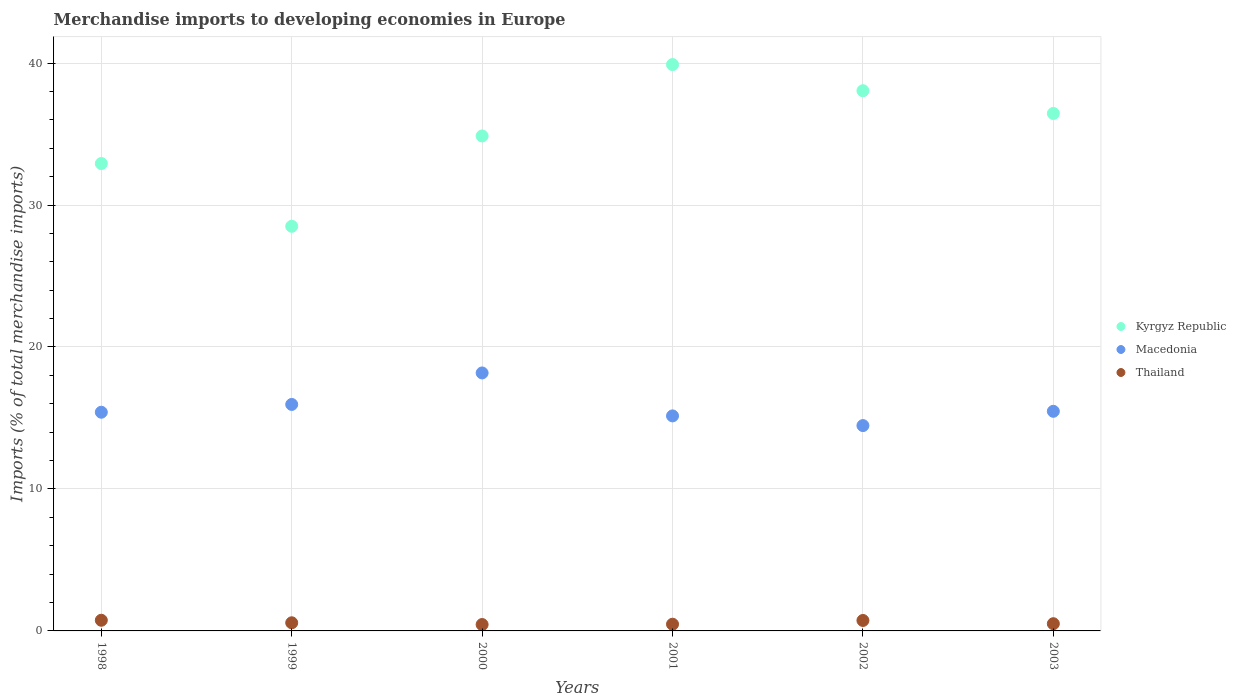How many different coloured dotlines are there?
Your answer should be compact. 3. What is the percentage total merchandise imports in Thailand in 2000?
Offer a very short reply. 0.45. Across all years, what is the maximum percentage total merchandise imports in Macedonia?
Offer a terse response. 18.17. Across all years, what is the minimum percentage total merchandise imports in Kyrgyz Republic?
Offer a very short reply. 28.5. In which year was the percentage total merchandise imports in Macedonia maximum?
Give a very brief answer. 2000. What is the total percentage total merchandise imports in Macedonia in the graph?
Ensure brevity in your answer.  94.61. What is the difference between the percentage total merchandise imports in Kyrgyz Republic in 1999 and that in 2000?
Your response must be concise. -6.36. What is the difference between the percentage total merchandise imports in Thailand in 1999 and the percentage total merchandise imports in Kyrgyz Republic in 2000?
Your answer should be compact. -34.29. What is the average percentage total merchandise imports in Thailand per year?
Make the answer very short. 0.58. In the year 2002, what is the difference between the percentage total merchandise imports in Thailand and percentage total merchandise imports in Macedonia?
Provide a short and direct response. -13.73. What is the ratio of the percentage total merchandise imports in Macedonia in 1999 to that in 2003?
Your answer should be very brief. 1.03. Is the difference between the percentage total merchandise imports in Thailand in 2000 and 2003 greater than the difference between the percentage total merchandise imports in Macedonia in 2000 and 2003?
Your response must be concise. No. What is the difference between the highest and the second highest percentage total merchandise imports in Kyrgyz Republic?
Ensure brevity in your answer.  1.84. What is the difference between the highest and the lowest percentage total merchandise imports in Macedonia?
Provide a succinct answer. 3.71. Is it the case that in every year, the sum of the percentage total merchandise imports in Thailand and percentage total merchandise imports in Kyrgyz Republic  is greater than the percentage total merchandise imports in Macedonia?
Give a very brief answer. Yes. Does the percentage total merchandise imports in Kyrgyz Republic monotonically increase over the years?
Keep it short and to the point. No. Is the percentage total merchandise imports in Macedonia strictly greater than the percentage total merchandise imports in Kyrgyz Republic over the years?
Provide a short and direct response. No. Are the values on the major ticks of Y-axis written in scientific E-notation?
Provide a short and direct response. No. Does the graph contain grids?
Give a very brief answer. Yes. How are the legend labels stacked?
Offer a very short reply. Vertical. What is the title of the graph?
Provide a short and direct response. Merchandise imports to developing economies in Europe. What is the label or title of the X-axis?
Make the answer very short. Years. What is the label or title of the Y-axis?
Offer a very short reply. Imports (% of total merchandise imports). What is the Imports (% of total merchandise imports) in Kyrgyz Republic in 1998?
Your answer should be compact. 32.92. What is the Imports (% of total merchandise imports) of Macedonia in 1998?
Ensure brevity in your answer.  15.4. What is the Imports (% of total merchandise imports) in Thailand in 1998?
Ensure brevity in your answer.  0.75. What is the Imports (% of total merchandise imports) of Kyrgyz Republic in 1999?
Make the answer very short. 28.5. What is the Imports (% of total merchandise imports) of Macedonia in 1999?
Your response must be concise. 15.95. What is the Imports (% of total merchandise imports) in Thailand in 1999?
Give a very brief answer. 0.57. What is the Imports (% of total merchandise imports) in Kyrgyz Republic in 2000?
Offer a terse response. 34.86. What is the Imports (% of total merchandise imports) of Macedonia in 2000?
Make the answer very short. 18.17. What is the Imports (% of total merchandise imports) of Thailand in 2000?
Offer a terse response. 0.45. What is the Imports (% of total merchandise imports) of Kyrgyz Republic in 2001?
Make the answer very short. 39.89. What is the Imports (% of total merchandise imports) of Macedonia in 2001?
Offer a terse response. 15.15. What is the Imports (% of total merchandise imports) of Thailand in 2001?
Provide a succinct answer. 0.47. What is the Imports (% of total merchandise imports) in Kyrgyz Republic in 2002?
Provide a short and direct response. 38.05. What is the Imports (% of total merchandise imports) in Macedonia in 2002?
Your answer should be very brief. 14.46. What is the Imports (% of total merchandise imports) of Thailand in 2002?
Your answer should be very brief. 0.74. What is the Imports (% of total merchandise imports) of Kyrgyz Republic in 2003?
Your answer should be very brief. 36.45. What is the Imports (% of total merchandise imports) in Macedonia in 2003?
Offer a terse response. 15.47. What is the Imports (% of total merchandise imports) in Thailand in 2003?
Provide a succinct answer. 0.51. Across all years, what is the maximum Imports (% of total merchandise imports) in Kyrgyz Republic?
Your response must be concise. 39.89. Across all years, what is the maximum Imports (% of total merchandise imports) of Macedonia?
Ensure brevity in your answer.  18.17. Across all years, what is the maximum Imports (% of total merchandise imports) of Thailand?
Your response must be concise. 0.75. Across all years, what is the minimum Imports (% of total merchandise imports) of Kyrgyz Republic?
Your answer should be very brief. 28.5. Across all years, what is the minimum Imports (% of total merchandise imports) of Macedonia?
Keep it short and to the point. 14.46. Across all years, what is the minimum Imports (% of total merchandise imports) of Thailand?
Offer a terse response. 0.45. What is the total Imports (% of total merchandise imports) of Kyrgyz Republic in the graph?
Keep it short and to the point. 210.68. What is the total Imports (% of total merchandise imports) of Macedonia in the graph?
Provide a short and direct response. 94.61. What is the total Imports (% of total merchandise imports) of Thailand in the graph?
Your response must be concise. 3.49. What is the difference between the Imports (% of total merchandise imports) of Kyrgyz Republic in 1998 and that in 1999?
Provide a short and direct response. 4.42. What is the difference between the Imports (% of total merchandise imports) in Macedonia in 1998 and that in 1999?
Provide a succinct answer. -0.55. What is the difference between the Imports (% of total merchandise imports) in Thailand in 1998 and that in 1999?
Ensure brevity in your answer.  0.18. What is the difference between the Imports (% of total merchandise imports) of Kyrgyz Republic in 1998 and that in 2000?
Your response must be concise. -1.94. What is the difference between the Imports (% of total merchandise imports) in Macedonia in 1998 and that in 2000?
Offer a very short reply. -2.77. What is the difference between the Imports (% of total merchandise imports) of Thailand in 1998 and that in 2000?
Your answer should be very brief. 0.3. What is the difference between the Imports (% of total merchandise imports) in Kyrgyz Republic in 1998 and that in 2001?
Your response must be concise. -6.97. What is the difference between the Imports (% of total merchandise imports) of Macedonia in 1998 and that in 2001?
Offer a very short reply. 0.26. What is the difference between the Imports (% of total merchandise imports) in Thailand in 1998 and that in 2001?
Your response must be concise. 0.28. What is the difference between the Imports (% of total merchandise imports) in Kyrgyz Republic in 1998 and that in 2002?
Offer a very short reply. -5.13. What is the difference between the Imports (% of total merchandise imports) in Macedonia in 1998 and that in 2002?
Offer a very short reply. 0.94. What is the difference between the Imports (% of total merchandise imports) of Thailand in 1998 and that in 2002?
Keep it short and to the point. 0.01. What is the difference between the Imports (% of total merchandise imports) in Kyrgyz Republic in 1998 and that in 2003?
Provide a short and direct response. -3.53. What is the difference between the Imports (% of total merchandise imports) of Macedonia in 1998 and that in 2003?
Your answer should be very brief. -0.07. What is the difference between the Imports (% of total merchandise imports) of Thailand in 1998 and that in 2003?
Give a very brief answer. 0.24. What is the difference between the Imports (% of total merchandise imports) in Kyrgyz Republic in 1999 and that in 2000?
Give a very brief answer. -6.36. What is the difference between the Imports (% of total merchandise imports) in Macedonia in 1999 and that in 2000?
Offer a very short reply. -2.22. What is the difference between the Imports (% of total merchandise imports) in Thailand in 1999 and that in 2000?
Give a very brief answer. 0.12. What is the difference between the Imports (% of total merchandise imports) in Kyrgyz Republic in 1999 and that in 2001?
Offer a very short reply. -11.39. What is the difference between the Imports (% of total merchandise imports) of Macedonia in 1999 and that in 2001?
Your answer should be compact. 0.81. What is the difference between the Imports (% of total merchandise imports) in Thailand in 1999 and that in 2001?
Ensure brevity in your answer.  0.1. What is the difference between the Imports (% of total merchandise imports) in Kyrgyz Republic in 1999 and that in 2002?
Give a very brief answer. -9.55. What is the difference between the Imports (% of total merchandise imports) of Macedonia in 1999 and that in 2002?
Ensure brevity in your answer.  1.49. What is the difference between the Imports (% of total merchandise imports) in Thailand in 1999 and that in 2002?
Offer a terse response. -0.16. What is the difference between the Imports (% of total merchandise imports) in Kyrgyz Republic in 1999 and that in 2003?
Your response must be concise. -7.95. What is the difference between the Imports (% of total merchandise imports) of Macedonia in 1999 and that in 2003?
Give a very brief answer. 0.48. What is the difference between the Imports (% of total merchandise imports) in Thailand in 1999 and that in 2003?
Offer a terse response. 0.06. What is the difference between the Imports (% of total merchandise imports) in Kyrgyz Republic in 2000 and that in 2001?
Offer a very short reply. -5.03. What is the difference between the Imports (% of total merchandise imports) of Macedonia in 2000 and that in 2001?
Provide a succinct answer. 3.03. What is the difference between the Imports (% of total merchandise imports) of Thailand in 2000 and that in 2001?
Keep it short and to the point. -0.02. What is the difference between the Imports (% of total merchandise imports) of Kyrgyz Republic in 2000 and that in 2002?
Make the answer very short. -3.19. What is the difference between the Imports (% of total merchandise imports) in Macedonia in 2000 and that in 2002?
Make the answer very short. 3.71. What is the difference between the Imports (% of total merchandise imports) in Thailand in 2000 and that in 2002?
Provide a succinct answer. -0.29. What is the difference between the Imports (% of total merchandise imports) of Kyrgyz Republic in 2000 and that in 2003?
Offer a terse response. -1.58. What is the difference between the Imports (% of total merchandise imports) of Macedonia in 2000 and that in 2003?
Your answer should be very brief. 2.7. What is the difference between the Imports (% of total merchandise imports) in Thailand in 2000 and that in 2003?
Provide a short and direct response. -0.06. What is the difference between the Imports (% of total merchandise imports) of Kyrgyz Republic in 2001 and that in 2002?
Provide a short and direct response. 1.84. What is the difference between the Imports (% of total merchandise imports) of Macedonia in 2001 and that in 2002?
Your answer should be very brief. 0.68. What is the difference between the Imports (% of total merchandise imports) in Thailand in 2001 and that in 2002?
Offer a terse response. -0.26. What is the difference between the Imports (% of total merchandise imports) in Kyrgyz Republic in 2001 and that in 2003?
Your response must be concise. 3.44. What is the difference between the Imports (% of total merchandise imports) in Macedonia in 2001 and that in 2003?
Offer a very short reply. -0.32. What is the difference between the Imports (% of total merchandise imports) of Thailand in 2001 and that in 2003?
Keep it short and to the point. -0.04. What is the difference between the Imports (% of total merchandise imports) in Kyrgyz Republic in 2002 and that in 2003?
Your answer should be very brief. 1.6. What is the difference between the Imports (% of total merchandise imports) in Macedonia in 2002 and that in 2003?
Your answer should be compact. -1.01. What is the difference between the Imports (% of total merchandise imports) in Thailand in 2002 and that in 2003?
Your answer should be compact. 0.23. What is the difference between the Imports (% of total merchandise imports) in Kyrgyz Republic in 1998 and the Imports (% of total merchandise imports) in Macedonia in 1999?
Keep it short and to the point. 16.97. What is the difference between the Imports (% of total merchandise imports) in Kyrgyz Republic in 1998 and the Imports (% of total merchandise imports) in Thailand in 1999?
Make the answer very short. 32.35. What is the difference between the Imports (% of total merchandise imports) of Macedonia in 1998 and the Imports (% of total merchandise imports) of Thailand in 1999?
Your response must be concise. 14.83. What is the difference between the Imports (% of total merchandise imports) in Kyrgyz Republic in 1998 and the Imports (% of total merchandise imports) in Macedonia in 2000?
Offer a terse response. 14.75. What is the difference between the Imports (% of total merchandise imports) in Kyrgyz Republic in 1998 and the Imports (% of total merchandise imports) in Thailand in 2000?
Your response must be concise. 32.47. What is the difference between the Imports (% of total merchandise imports) of Macedonia in 1998 and the Imports (% of total merchandise imports) of Thailand in 2000?
Make the answer very short. 14.95. What is the difference between the Imports (% of total merchandise imports) of Kyrgyz Republic in 1998 and the Imports (% of total merchandise imports) of Macedonia in 2001?
Offer a very short reply. 17.77. What is the difference between the Imports (% of total merchandise imports) of Kyrgyz Republic in 1998 and the Imports (% of total merchandise imports) of Thailand in 2001?
Your answer should be compact. 32.45. What is the difference between the Imports (% of total merchandise imports) in Macedonia in 1998 and the Imports (% of total merchandise imports) in Thailand in 2001?
Your answer should be compact. 14.93. What is the difference between the Imports (% of total merchandise imports) of Kyrgyz Republic in 1998 and the Imports (% of total merchandise imports) of Macedonia in 2002?
Provide a short and direct response. 18.46. What is the difference between the Imports (% of total merchandise imports) of Kyrgyz Republic in 1998 and the Imports (% of total merchandise imports) of Thailand in 2002?
Your response must be concise. 32.19. What is the difference between the Imports (% of total merchandise imports) in Macedonia in 1998 and the Imports (% of total merchandise imports) in Thailand in 2002?
Offer a very short reply. 14.67. What is the difference between the Imports (% of total merchandise imports) of Kyrgyz Republic in 1998 and the Imports (% of total merchandise imports) of Macedonia in 2003?
Your answer should be very brief. 17.45. What is the difference between the Imports (% of total merchandise imports) in Kyrgyz Republic in 1998 and the Imports (% of total merchandise imports) in Thailand in 2003?
Provide a short and direct response. 32.41. What is the difference between the Imports (% of total merchandise imports) of Macedonia in 1998 and the Imports (% of total merchandise imports) of Thailand in 2003?
Provide a short and direct response. 14.9. What is the difference between the Imports (% of total merchandise imports) in Kyrgyz Republic in 1999 and the Imports (% of total merchandise imports) in Macedonia in 2000?
Provide a short and direct response. 10.33. What is the difference between the Imports (% of total merchandise imports) of Kyrgyz Republic in 1999 and the Imports (% of total merchandise imports) of Thailand in 2000?
Provide a succinct answer. 28.05. What is the difference between the Imports (% of total merchandise imports) in Macedonia in 1999 and the Imports (% of total merchandise imports) in Thailand in 2000?
Provide a short and direct response. 15.5. What is the difference between the Imports (% of total merchandise imports) in Kyrgyz Republic in 1999 and the Imports (% of total merchandise imports) in Macedonia in 2001?
Your response must be concise. 13.36. What is the difference between the Imports (% of total merchandise imports) in Kyrgyz Republic in 1999 and the Imports (% of total merchandise imports) in Thailand in 2001?
Keep it short and to the point. 28.03. What is the difference between the Imports (% of total merchandise imports) in Macedonia in 1999 and the Imports (% of total merchandise imports) in Thailand in 2001?
Provide a succinct answer. 15.48. What is the difference between the Imports (% of total merchandise imports) of Kyrgyz Republic in 1999 and the Imports (% of total merchandise imports) of Macedonia in 2002?
Provide a short and direct response. 14.04. What is the difference between the Imports (% of total merchandise imports) in Kyrgyz Republic in 1999 and the Imports (% of total merchandise imports) in Thailand in 2002?
Make the answer very short. 27.77. What is the difference between the Imports (% of total merchandise imports) of Macedonia in 1999 and the Imports (% of total merchandise imports) of Thailand in 2002?
Keep it short and to the point. 15.22. What is the difference between the Imports (% of total merchandise imports) of Kyrgyz Republic in 1999 and the Imports (% of total merchandise imports) of Macedonia in 2003?
Provide a succinct answer. 13.03. What is the difference between the Imports (% of total merchandise imports) in Kyrgyz Republic in 1999 and the Imports (% of total merchandise imports) in Thailand in 2003?
Offer a terse response. 27.99. What is the difference between the Imports (% of total merchandise imports) in Macedonia in 1999 and the Imports (% of total merchandise imports) in Thailand in 2003?
Provide a short and direct response. 15.45. What is the difference between the Imports (% of total merchandise imports) in Kyrgyz Republic in 2000 and the Imports (% of total merchandise imports) in Macedonia in 2001?
Keep it short and to the point. 19.72. What is the difference between the Imports (% of total merchandise imports) of Kyrgyz Republic in 2000 and the Imports (% of total merchandise imports) of Thailand in 2001?
Ensure brevity in your answer.  34.39. What is the difference between the Imports (% of total merchandise imports) in Macedonia in 2000 and the Imports (% of total merchandise imports) in Thailand in 2001?
Offer a terse response. 17.7. What is the difference between the Imports (% of total merchandise imports) of Kyrgyz Republic in 2000 and the Imports (% of total merchandise imports) of Macedonia in 2002?
Offer a terse response. 20.4. What is the difference between the Imports (% of total merchandise imports) in Kyrgyz Republic in 2000 and the Imports (% of total merchandise imports) in Thailand in 2002?
Your response must be concise. 34.13. What is the difference between the Imports (% of total merchandise imports) of Macedonia in 2000 and the Imports (% of total merchandise imports) of Thailand in 2002?
Offer a very short reply. 17.44. What is the difference between the Imports (% of total merchandise imports) in Kyrgyz Republic in 2000 and the Imports (% of total merchandise imports) in Macedonia in 2003?
Your answer should be compact. 19.39. What is the difference between the Imports (% of total merchandise imports) of Kyrgyz Republic in 2000 and the Imports (% of total merchandise imports) of Thailand in 2003?
Your answer should be compact. 34.36. What is the difference between the Imports (% of total merchandise imports) in Macedonia in 2000 and the Imports (% of total merchandise imports) in Thailand in 2003?
Give a very brief answer. 17.66. What is the difference between the Imports (% of total merchandise imports) in Kyrgyz Republic in 2001 and the Imports (% of total merchandise imports) in Macedonia in 2002?
Provide a succinct answer. 25.43. What is the difference between the Imports (% of total merchandise imports) in Kyrgyz Republic in 2001 and the Imports (% of total merchandise imports) in Thailand in 2002?
Keep it short and to the point. 39.16. What is the difference between the Imports (% of total merchandise imports) of Macedonia in 2001 and the Imports (% of total merchandise imports) of Thailand in 2002?
Make the answer very short. 14.41. What is the difference between the Imports (% of total merchandise imports) in Kyrgyz Republic in 2001 and the Imports (% of total merchandise imports) in Macedonia in 2003?
Your response must be concise. 24.42. What is the difference between the Imports (% of total merchandise imports) of Kyrgyz Republic in 2001 and the Imports (% of total merchandise imports) of Thailand in 2003?
Provide a short and direct response. 39.38. What is the difference between the Imports (% of total merchandise imports) in Macedonia in 2001 and the Imports (% of total merchandise imports) in Thailand in 2003?
Offer a terse response. 14.64. What is the difference between the Imports (% of total merchandise imports) of Kyrgyz Republic in 2002 and the Imports (% of total merchandise imports) of Macedonia in 2003?
Provide a short and direct response. 22.58. What is the difference between the Imports (% of total merchandise imports) in Kyrgyz Republic in 2002 and the Imports (% of total merchandise imports) in Thailand in 2003?
Make the answer very short. 37.54. What is the difference between the Imports (% of total merchandise imports) of Macedonia in 2002 and the Imports (% of total merchandise imports) of Thailand in 2003?
Offer a very short reply. 13.96. What is the average Imports (% of total merchandise imports) of Kyrgyz Republic per year?
Make the answer very short. 35.11. What is the average Imports (% of total merchandise imports) in Macedonia per year?
Give a very brief answer. 15.77. What is the average Imports (% of total merchandise imports) in Thailand per year?
Make the answer very short. 0.58. In the year 1998, what is the difference between the Imports (% of total merchandise imports) of Kyrgyz Republic and Imports (% of total merchandise imports) of Macedonia?
Offer a very short reply. 17.52. In the year 1998, what is the difference between the Imports (% of total merchandise imports) of Kyrgyz Republic and Imports (% of total merchandise imports) of Thailand?
Provide a succinct answer. 32.17. In the year 1998, what is the difference between the Imports (% of total merchandise imports) of Macedonia and Imports (% of total merchandise imports) of Thailand?
Offer a very short reply. 14.65. In the year 1999, what is the difference between the Imports (% of total merchandise imports) in Kyrgyz Republic and Imports (% of total merchandise imports) in Macedonia?
Make the answer very short. 12.55. In the year 1999, what is the difference between the Imports (% of total merchandise imports) in Kyrgyz Republic and Imports (% of total merchandise imports) in Thailand?
Give a very brief answer. 27.93. In the year 1999, what is the difference between the Imports (% of total merchandise imports) in Macedonia and Imports (% of total merchandise imports) in Thailand?
Give a very brief answer. 15.38. In the year 2000, what is the difference between the Imports (% of total merchandise imports) in Kyrgyz Republic and Imports (% of total merchandise imports) in Macedonia?
Keep it short and to the point. 16.69. In the year 2000, what is the difference between the Imports (% of total merchandise imports) in Kyrgyz Republic and Imports (% of total merchandise imports) in Thailand?
Provide a succinct answer. 34.41. In the year 2000, what is the difference between the Imports (% of total merchandise imports) in Macedonia and Imports (% of total merchandise imports) in Thailand?
Offer a terse response. 17.72. In the year 2001, what is the difference between the Imports (% of total merchandise imports) of Kyrgyz Republic and Imports (% of total merchandise imports) of Macedonia?
Provide a succinct answer. 24.75. In the year 2001, what is the difference between the Imports (% of total merchandise imports) in Kyrgyz Republic and Imports (% of total merchandise imports) in Thailand?
Provide a short and direct response. 39.42. In the year 2001, what is the difference between the Imports (% of total merchandise imports) of Macedonia and Imports (% of total merchandise imports) of Thailand?
Make the answer very short. 14.67. In the year 2002, what is the difference between the Imports (% of total merchandise imports) of Kyrgyz Republic and Imports (% of total merchandise imports) of Macedonia?
Your response must be concise. 23.59. In the year 2002, what is the difference between the Imports (% of total merchandise imports) in Kyrgyz Republic and Imports (% of total merchandise imports) in Thailand?
Provide a succinct answer. 37.31. In the year 2002, what is the difference between the Imports (% of total merchandise imports) in Macedonia and Imports (% of total merchandise imports) in Thailand?
Your answer should be compact. 13.73. In the year 2003, what is the difference between the Imports (% of total merchandise imports) of Kyrgyz Republic and Imports (% of total merchandise imports) of Macedonia?
Your answer should be compact. 20.98. In the year 2003, what is the difference between the Imports (% of total merchandise imports) of Kyrgyz Republic and Imports (% of total merchandise imports) of Thailand?
Make the answer very short. 35.94. In the year 2003, what is the difference between the Imports (% of total merchandise imports) in Macedonia and Imports (% of total merchandise imports) in Thailand?
Offer a terse response. 14.96. What is the ratio of the Imports (% of total merchandise imports) in Kyrgyz Republic in 1998 to that in 1999?
Provide a succinct answer. 1.16. What is the ratio of the Imports (% of total merchandise imports) in Macedonia in 1998 to that in 1999?
Provide a short and direct response. 0.97. What is the ratio of the Imports (% of total merchandise imports) in Thailand in 1998 to that in 1999?
Provide a succinct answer. 1.31. What is the ratio of the Imports (% of total merchandise imports) of Kyrgyz Republic in 1998 to that in 2000?
Keep it short and to the point. 0.94. What is the ratio of the Imports (% of total merchandise imports) of Macedonia in 1998 to that in 2000?
Provide a short and direct response. 0.85. What is the ratio of the Imports (% of total merchandise imports) of Thailand in 1998 to that in 2000?
Provide a short and direct response. 1.67. What is the ratio of the Imports (% of total merchandise imports) in Kyrgyz Republic in 1998 to that in 2001?
Provide a short and direct response. 0.83. What is the ratio of the Imports (% of total merchandise imports) in Thailand in 1998 to that in 2001?
Make the answer very short. 1.59. What is the ratio of the Imports (% of total merchandise imports) in Kyrgyz Republic in 1998 to that in 2002?
Your response must be concise. 0.87. What is the ratio of the Imports (% of total merchandise imports) in Macedonia in 1998 to that in 2002?
Offer a terse response. 1.06. What is the ratio of the Imports (% of total merchandise imports) in Thailand in 1998 to that in 2002?
Make the answer very short. 1.02. What is the ratio of the Imports (% of total merchandise imports) of Kyrgyz Republic in 1998 to that in 2003?
Offer a very short reply. 0.9. What is the ratio of the Imports (% of total merchandise imports) of Thailand in 1998 to that in 2003?
Offer a terse response. 1.48. What is the ratio of the Imports (% of total merchandise imports) of Kyrgyz Republic in 1999 to that in 2000?
Keep it short and to the point. 0.82. What is the ratio of the Imports (% of total merchandise imports) in Macedonia in 1999 to that in 2000?
Keep it short and to the point. 0.88. What is the ratio of the Imports (% of total merchandise imports) in Thailand in 1999 to that in 2000?
Your response must be concise. 1.27. What is the ratio of the Imports (% of total merchandise imports) of Kyrgyz Republic in 1999 to that in 2001?
Provide a succinct answer. 0.71. What is the ratio of the Imports (% of total merchandise imports) of Macedonia in 1999 to that in 2001?
Keep it short and to the point. 1.05. What is the ratio of the Imports (% of total merchandise imports) of Thailand in 1999 to that in 2001?
Make the answer very short. 1.21. What is the ratio of the Imports (% of total merchandise imports) of Kyrgyz Republic in 1999 to that in 2002?
Your answer should be very brief. 0.75. What is the ratio of the Imports (% of total merchandise imports) of Macedonia in 1999 to that in 2002?
Your response must be concise. 1.1. What is the ratio of the Imports (% of total merchandise imports) of Thailand in 1999 to that in 2002?
Make the answer very short. 0.78. What is the ratio of the Imports (% of total merchandise imports) in Kyrgyz Republic in 1999 to that in 2003?
Ensure brevity in your answer.  0.78. What is the ratio of the Imports (% of total merchandise imports) of Macedonia in 1999 to that in 2003?
Provide a succinct answer. 1.03. What is the ratio of the Imports (% of total merchandise imports) in Thailand in 1999 to that in 2003?
Offer a terse response. 1.13. What is the ratio of the Imports (% of total merchandise imports) of Kyrgyz Republic in 2000 to that in 2001?
Ensure brevity in your answer.  0.87. What is the ratio of the Imports (% of total merchandise imports) in Macedonia in 2000 to that in 2001?
Provide a short and direct response. 1.2. What is the ratio of the Imports (% of total merchandise imports) of Thailand in 2000 to that in 2001?
Give a very brief answer. 0.95. What is the ratio of the Imports (% of total merchandise imports) of Kyrgyz Republic in 2000 to that in 2002?
Give a very brief answer. 0.92. What is the ratio of the Imports (% of total merchandise imports) of Macedonia in 2000 to that in 2002?
Give a very brief answer. 1.26. What is the ratio of the Imports (% of total merchandise imports) of Thailand in 2000 to that in 2002?
Ensure brevity in your answer.  0.61. What is the ratio of the Imports (% of total merchandise imports) in Kyrgyz Republic in 2000 to that in 2003?
Offer a terse response. 0.96. What is the ratio of the Imports (% of total merchandise imports) in Macedonia in 2000 to that in 2003?
Make the answer very short. 1.17. What is the ratio of the Imports (% of total merchandise imports) of Thailand in 2000 to that in 2003?
Offer a very short reply. 0.89. What is the ratio of the Imports (% of total merchandise imports) of Kyrgyz Republic in 2001 to that in 2002?
Ensure brevity in your answer.  1.05. What is the ratio of the Imports (% of total merchandise imports) of Macedonia in 2001 to that in 2002?
Provide a short and direct response. 1.05. What is the ratio of the Imports (% of total merchandise imports) in Thailand in 2001 to that in 2002?
Offer a very short reply. 0.64. What is the ratio of the Imports (% of total merchandise imports) of Kyrgyz Republic in 2001 to that in 2003?
Ensure brevity in your answer.  1.09. What is the ratio of the Imports (% of total merchandise imports) in Macedonia in 2001 to that in 2003?
Keep it short and to the point. 0.98. What is the ratio of the Imports (% of total merchandise imports) in Thailand in 2001 to that in 2003?
Your answer should be very brief. 0.93. What is the ratio of the Imports (% of total merchandise imports) of Kyrgyz Republic in 2002 to that in 2003?
Your response must be concise. 1.04. What is the ratio of the Imports (% of total merchandise imports) of Macedonia in 2002 to that in 2003?
Make the answer very short. 0.94. What is the ratio of the Imports (% of total merchandise imports) of Thailand in 2002 to that in 2003?
Provide a short and direct response. 1.45. What is the difference between the highest and the second highest Imports (% of total merchandise imports) in Kyrgyz Republic?
Ensure brevity in your answer.  1.84. What is the difference between the highest and the second highest Imports (% of total merchandise imports) of Macedonia?
Offer a terse response. 2.22. What is the difference between the highest and the second highest Imports (% of total merchandise imports) of Thailand?
Your response must be concise. 0.01. What is the difference between the highest and the lowest Imports (% of total merchandise imports) of Kyrgyz Republic?
Offer a very short reply. 11.39. What is the difference between the highest and the lowest Imports (% of total merchandise imports) in Macedonia?
Keep it short and to the point. 3.71. What is the difference between the highest and the lowest Imports (% of total merchandise imports) of Thailand?
Provide a short and direct response. 0.3. 